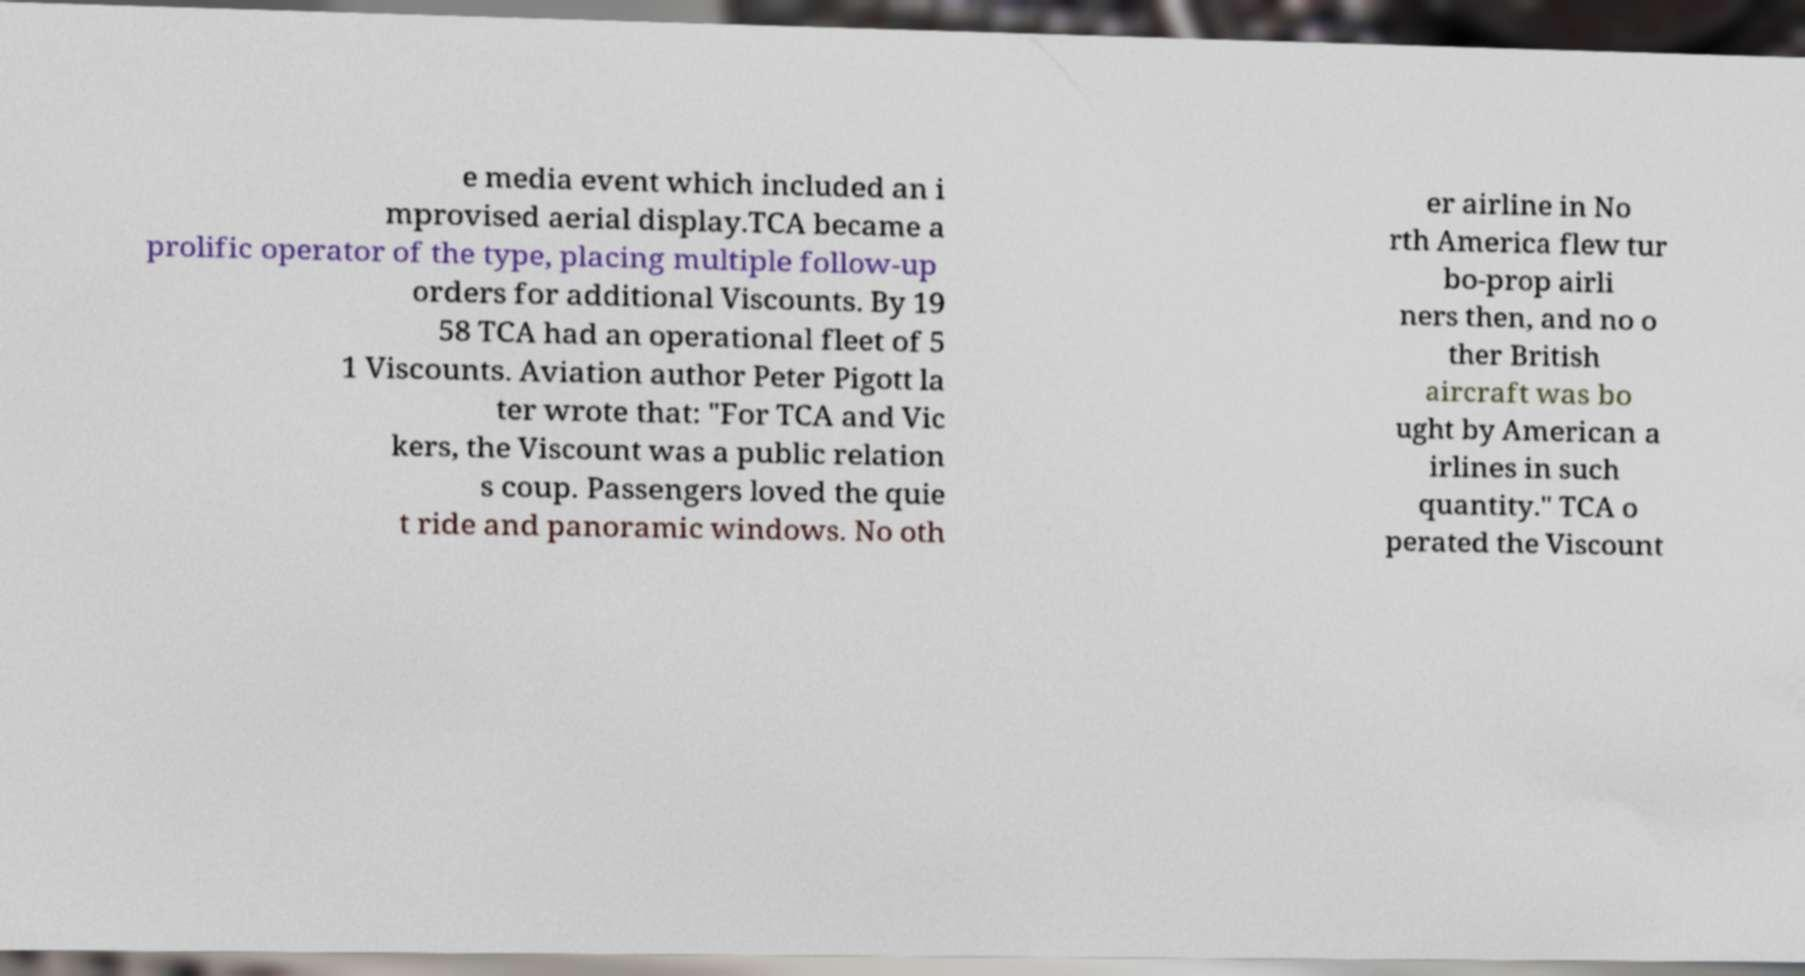Can you accurately transcribe the text from the provided image for me? e media event which included an i mprovised aerial display.TCA became a prolific operator of the type, placing multiple follow-up orders for additional Viscounts. By 19 58 TCA had an operational fleet of 5 1 Viscounts. Aviation author Peter Pigott la ter wrote that: "For TCA and Vic kers, the Viscount was a public relation s coup. Passengers loved the quie t ride and panoramic windows. No oth er airline in No rth America flew tur bo-prop airli ners then, and no o ther British aircraft was bo ught by American a irlines in such quantity." TCA o perated the Viscount 